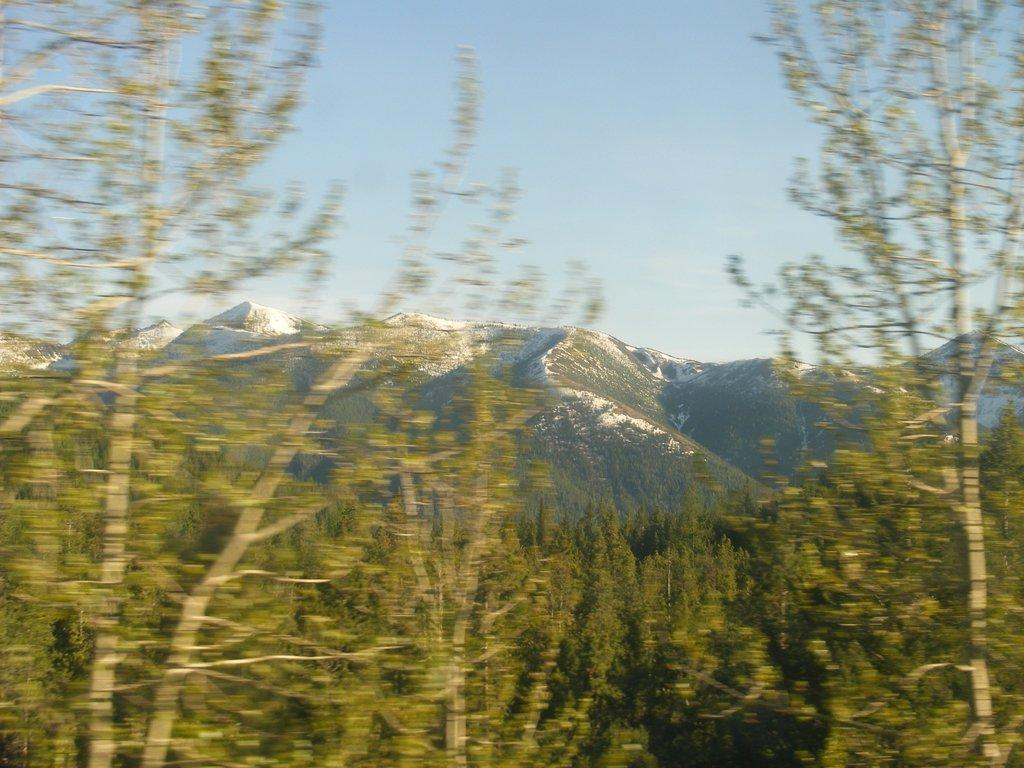What type of natural features can be seen in the image? There are trees and mountains in the image. What is visible in the background of the image? The sky is visible in the background of the image. What type of music can be heard coming from the trees in the image? There is no music present in the image, as it features trees and mountains without any audible sounds. 